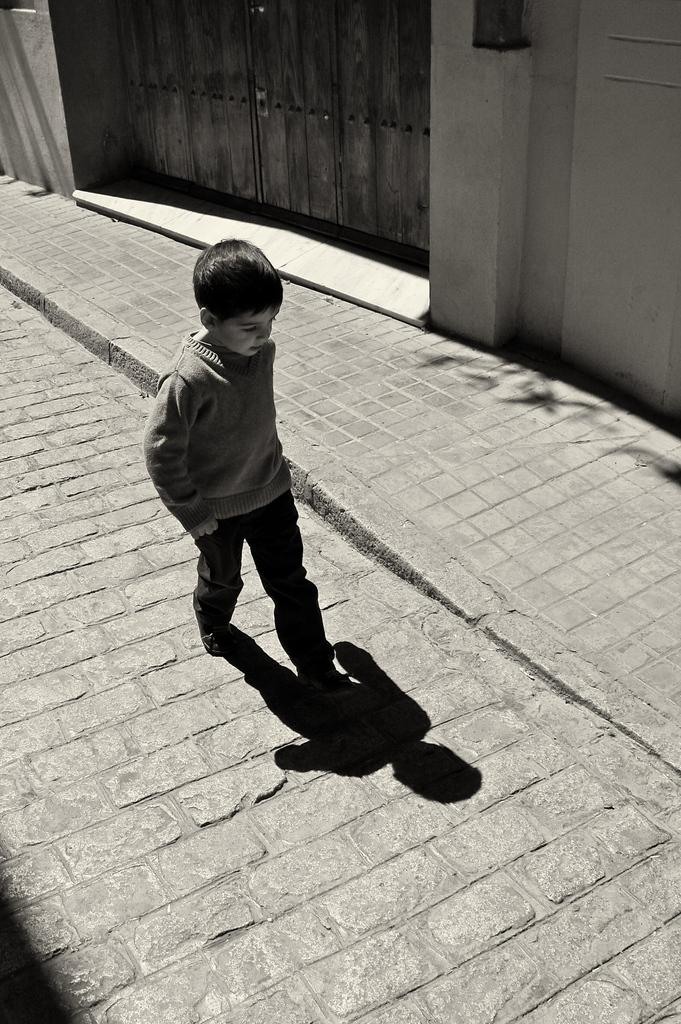What is the color scheme of the image? The image is black and white. What is the main subject of the image? There is a kid in the center of the image. What is the kid doing in the image? The kid is walking. What can be seen in the background of the image? There is a wall and a gate in the background of the image. What else is visible in the image besides the kid and the background? The kid's shadow is visible in the image. How does the earthquake affect the kid's walking in the image? There is no earthquake present in the image, so its effect on the kid's walking cannot be determined. What type of maid is present in the image? There is no maid present in the image. 